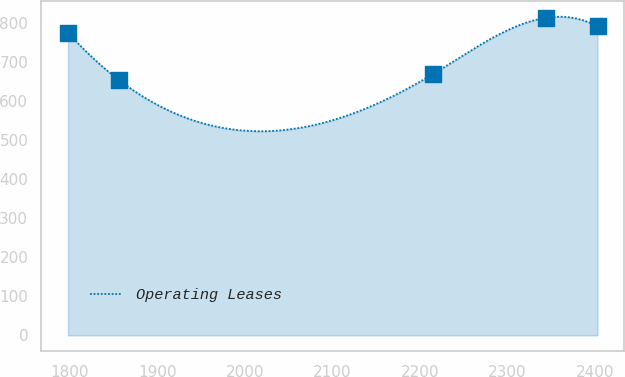Convert chart to OTSL. <chart><loc_0><loc_0><loc_500><loc_500><line_chart><ecel><fcel>Operating Leases<nl><fcel>1797.74<fcel>775.91<nl><fcel>1856.64<fcel>653.61<nl><fcel>2215.02<fcel>669.67<nl><fcel>2344.4<fcel>814.26<nl><fcel>2403.3<fcel>791.97<nl></chart> 